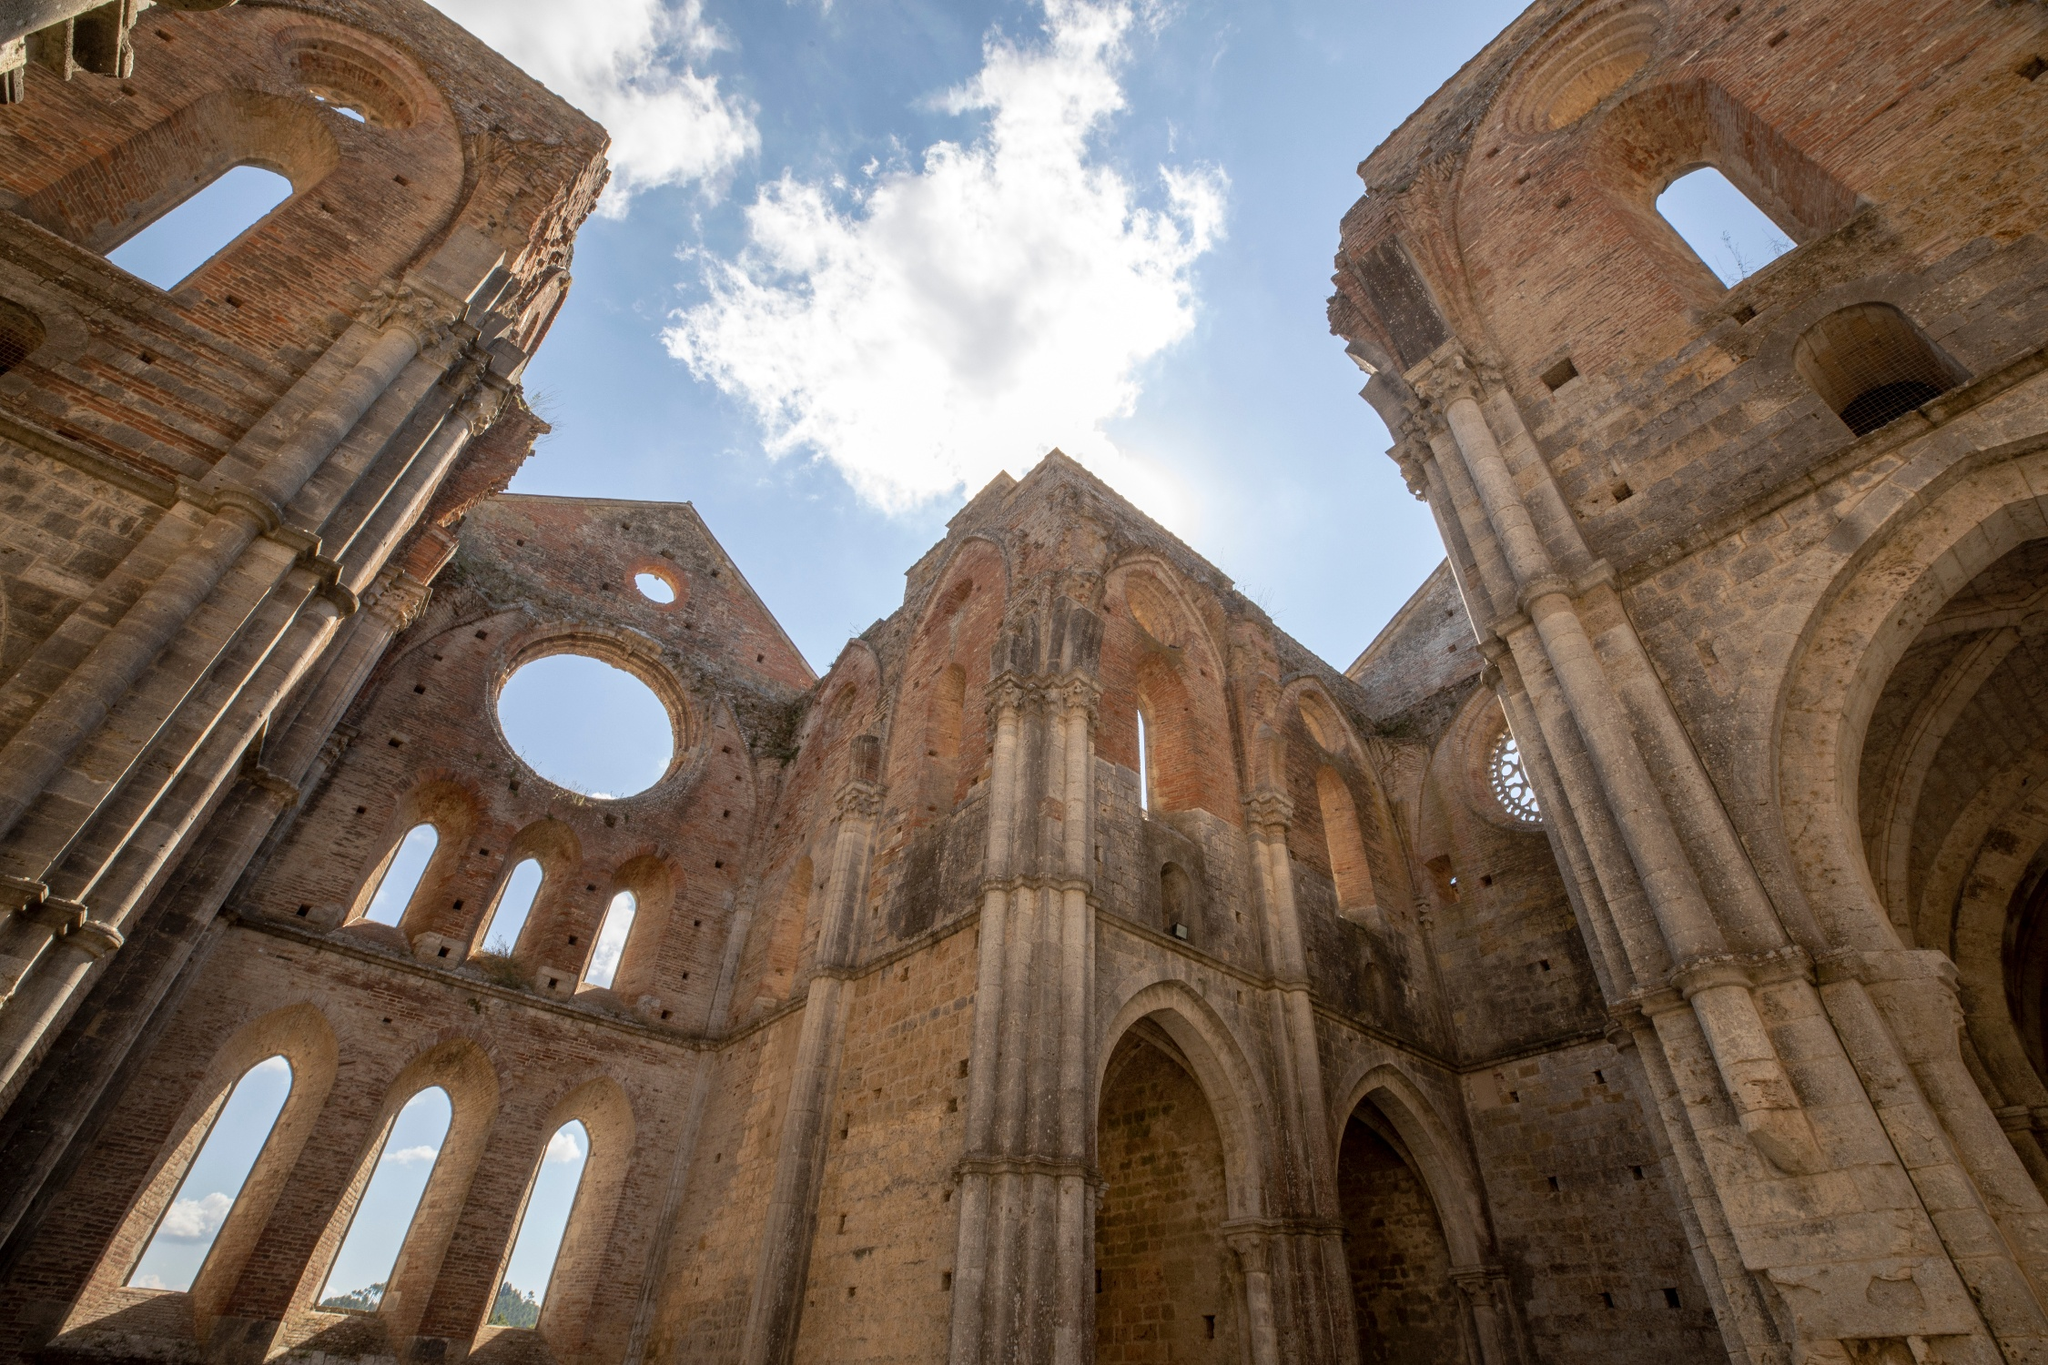What can you infer about the historical significance of this structure from the image? The structure depicted in the image suggests a location of great historical significance, likely an ancient church or cathedral. The architectural style, characterized by towering arches and detailed stonework, indicates it could be from the Gothic or Romanesque period, commonly seen between the 12th and 16th centuries in Europe. The size and the intricate design suggest it was once a site of considerable importance, potentially serving as a central place of worship, community gatherings, and possibly even a pilgrimage destination. The current state of ruin can imply several centuries of history, weathering, and possibly events such as wars, indicating a rich and tumultuous past. Imagine a scenario where an archeologist discovers an ancient artifacts inside these ruins. Describe the scene. As the archeologist carefully makes their way through the desolate ruins of the ancient church, the echoing silence is broken only by the soft rustle of their footsteps against the crumbling stone floor. Sunlight streams through the shattered windows, casting a mosaic of light and shadow across the decaying pillars. The archaeologist, clad in a weathered hat and dust-covered vest, gently brushes away centuries of debris to reveal a glimmering artifact. The golden chalice, encrusted with precious stones, hints at its regal past, perhaps once held aloft during grand ceremonies in this very sanctuary. The archeologist's breath catches as they lift the relic, imagining the countless hands that shaped it, held it, and revered its presence through the annals of history. Can you make up an extremely creative story involving a dragon and these ruins? In a time long forgotten, within the hollowed ruins of an ancient cathedral, there once dwelled a majestic dragon named Arion. Unlike any other dragon in lore, Arion was a guardian, his azure scales shimmering like the clear sky above, his presence both awe-inspiring and foreboding. The cathedral, built centuries before by a secretive sect of monks, was believed to be the gateway to an ethereal realm—a realm Arion was sworn to protect.

Legends spoke of a hidden treasure, an ancient relic with the power to bridge worlds, concealed within the cathedral's stone walls. As generations passed, many ventured into the ruins, their hearts driven by greed and ambition, but none could bypass Arion's vigilant watch. The dragon, wise and just, tested each with riddles as old as time itself, deeming only the pure of heart worthy to glimpse the sacred trove.

One fateful day, a young scribe named Elara, with nothing but a tattered journal and a heart full of wonder, stumbled upon the ruins. Unlike others, her quest was fueled not by wealth but by an insatiable curiosity and a desire to chronicle the world’s mysteries. Upon encountering Arion, she did not cower but instead marveled at his grandeur and serenely recited verses from ancient texts she had studied.

Moved by her genuine spirit, Arion allowed Elara to traverse the sacred ruins. As she reached the heart of the cathedral, she discovered the relic—an ornate mirror framed in woven gold and encrusted jewels. It was not treasure but a portal, reflecting the soul's true desires. Elara, seeing her loving family and her lifelong dream fulfilled, thanked Arion and departed, leaving the relic untouched.

The dragon smiled, knowing the cathedral’s secret remained guarded by Elara’s virtue, and continued his eternal watch, bound not by chains but by an oath to protect the link between worlds. Imagine you are writing a travel blog about this cathedral. Summarize your experience. Nestled amidst a serene valley, the majestic ruins of the ancient cathedral stand as a testament to time and history, a site that left me in quiet awe. As I wandered through the towering arches and intricate stonework, I felt an overwhelming sense of stepping into another epoch, where every brick whispered tales of devotion and grandeur. The play of sunlight through the hollowed windows created a surreal ambiance, casting shadows that danced on the weathered stone. The serenity and the sheer scale of the ruins made for a contemplative journey, far removed from the hustle of daily life. It wasn't just a visit; it was an immersion into history, a moment of connection with the souls who once filled these sacred halls. 